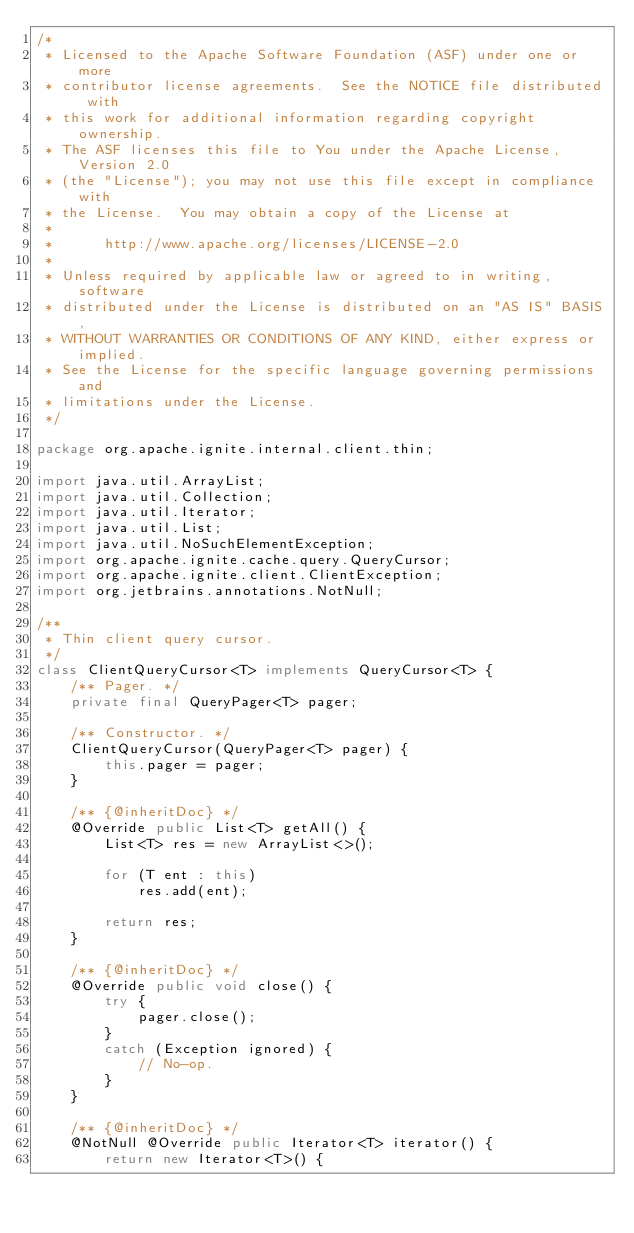Convert code to text. <code><loc_0><loc_0><loc_500><loc_500><_Java_>/*
 * Licensed to the Apache Software Foundation (ASF) under one or more
 * contributor license agreements.  See the NOTICE file distributed with
 * this work for additional information regarding copyright ownership.
 * The ASF licenses this file to You under the Apache License, Version 2.0
 * (the "License"); you may not use this file except in compliance with
 * the License.  You may obtain a copy of the License at
 *
 *      http://www.apache.org/licenses/LICENSE-2.0
 *
 * Unless required by applicable law or agreed to in writing, software
 * distributed under the License is distributed on an "AS IS" BASIS,
 * WITHOUT WARRANTIES OR CONDITIONS OF ANY KIND, either express or implied.
 * See the License for the specific language governing permissions and
 * limitations under the License.
 */

package org.apache.ignite.internal.client.thin;

import java.util.ArrayList;
import java.util.Collection;
import java.util.Iterator;
import java.util.List;
import java.util.NoSuchElementException;
import org.apache.ignite.cache.query.QueryCursor;
import org.apache.ignite.client.ClientException;
import org.jetbrains.annotations.NotNull;

/**
 * Thin client query cursor.
 */
class ClientQueryCursor<T> implements QueryCursor<T> {
    /** Pager. */
    private final QueryPager<T> pager;

    /** Constructor. */
    ClientQueryCursor(QueryPager<T> pager) {
        this.pager = pager;
    }

    /** {@inheritDoc} */
    @Override public List<T> getAll() {
        List<T> res = new ArrayList<>();

        for (T ent : this)
            res.add(ent);

        return res;
    }

    /** {@inheritDoc} */
    @Override public void close() {
        try {
            pager.close();
        }
        catch (Exception ignored) {
            // No-op.
        }
    }

    /** {@inheritDoc} */
    @NotNull @Override public Iterator<T> iterator() {
        return new Iterator<T>() {</code> 